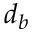<formula> <loc_0><loc_0><loc_500><loc_500>d _ { b }</formula> 